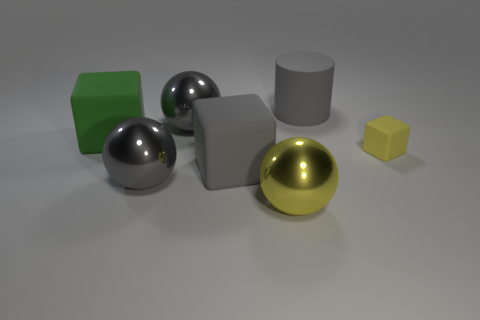Add 2 large gray matte cubes. How many objects exist? 9 Subtract all blocks. How many objects are left? 4 Subtract 1 yellow spheres. How many objects are left? 6 Subtract all small yellow objects. Subtract all big metal spheres. How many objects are left? 3 Add 7 gray cylinders. How many gray cylinders are left? 8 Add 3 large cylinders. How many large cylinders exist? 4 